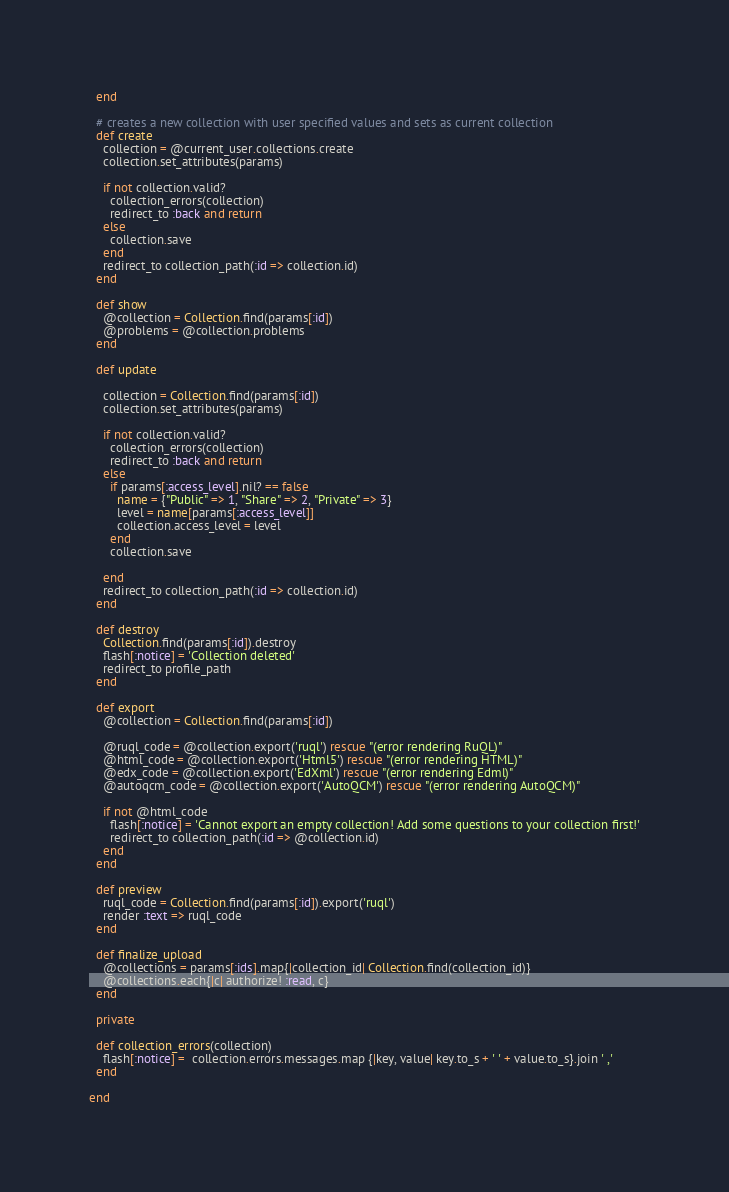<code> <loc_0><loc_0><loc_500><loc_500><_Ruby_>  end

  # creates a new collection with user specified values and sets as current collection
  def create
    collection = @current_user.collections.create
    collection.set_attributes(params)

    if not collection.valid?
      collection_errors(collection)
      redirect_to :back and return
    else
      collection.save
    end
    redirect_to collection_path(:id => collection.id)
  end

  def show
    @collection = Collection.find(params[:id])
    @problems = @collection.problems
  end

  def update

    collection = Collection.find(params[:id])
    collection.set_attributes(params)

    if not collection.valid?
      collection_errors(collection)
      redirect_to :back and return
    else
      if params[:access_level].nil? == false
        name = {"Public" => 1, "Share" => 2, "Private" => 3}
        level = name[params[:access_level]]
        collection.access_level = level
      end
      collection.save

    end
    redirect_to collection_path(:id => collection.id)
  end

  def destroy
    Collection.find(params[:id]).destroy
    flash[:notice] = 'Collection deleted'
    redirect_to profile_path
  end

  def export
    @collection = Collection.find(params[:id])

    @ruql_code = @collection.export('ruql') rescue "(error rendering RuQL)"
    @html_code = @collection.export('Html5') rescue "(error rendering HTML)"
    @edx_code = @collection.export('EdXml') rescue "(error rendering Edml)"
    @autoqcm_code = @collection.export('AutoQCM') rescue "(error rendering AutoQCM)"

    if not @html_code
      flash[:notice] = 'Cannot export an empty collection! Add some questions to your collection first!'
      redirect_to collection_path(:id => @collection.id)
    end
  end

  def preview
    ruql_code = Collection.find(params[:id]).export('ruql')
    render :text => ruql_code
  end

  def finalize_upload
    @collections = params[:ids].map{|collection_id| Collection.find(collection_id)}
    @collections.each{|c| authorize! :read, c}
  end

  private

  def collection_errors(collection)
    flash[:notice] =  collection.errors.messages.map {|key, value| key.to_s + ' ' + value.to_s}.join ' ,'
  end

end
</code> 